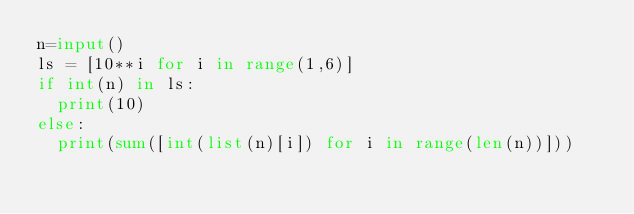<code> <loc_0><loc_0><loc_500><loc_500><_Python_>n=input()
ls = [10**i for i in range(1,6)]
if int(n) in ls:
  print(10)
else:
  print(sum([int(list(n)[i]) for i in range(len(n))]))</code> 